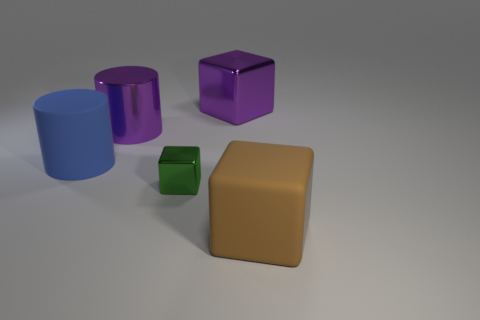There is a shiny object that is the same color as the large shiny cylinder; what is its size?
Ensure brevity in your answer.  Large. The purple shiny thing that is in front of the big purple thing that is on the right side of the metallic object that is in front of the big blue cylinder is what shape?
Provide a succinct answer. Cylinder. Are the large cube that is behind the big matte block and the cylinder that is on the right side of the blue matte cylinder made of the same material?
Provide a short and direct response. Yes. There is a tiny metallic object on the left side of the large brown rubber thing; what shape is it?
Ensure brevity in your answer.  Cube. Is the number of large purple things less than the number of big brown spheres?
Your answer should be very brief. No. Are there any blue cylinders in front of the large matte object behind the big rubber thing right of the big metal cube?
Provide a short and direct response. No. What number of shiny things are either gray things or big purple cubes?
Make the answer very short. 1. Is the color of the big metal cylinder the same as the small metallic cube?
Offer a very short reply. No. There is a small green cube; what number of metallic blocks are to the right of it?
Your answer should be very brief. 1. What number of rubber objects are on the right side of the large rubber cylinder and left of the small shiny object?
Your response must be concise. 0. 